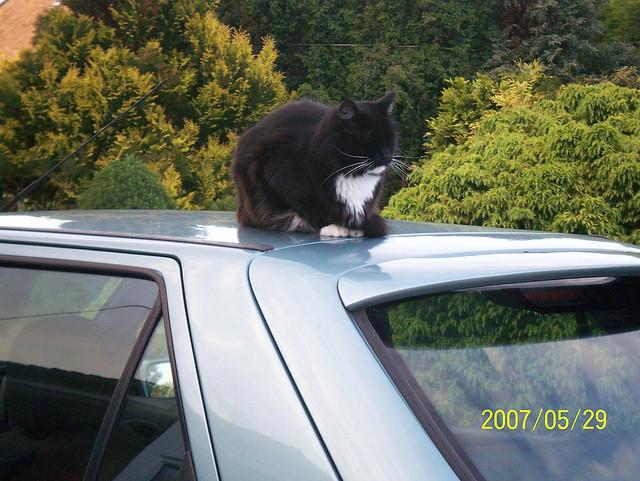Is this car moving?
Answer briefly. No. What color is the cat?
Quick response, please. Black. Where is the cat?
Quick response, please. On car. Who is looking out from the vehicle?
Concise answer only. Cat. 